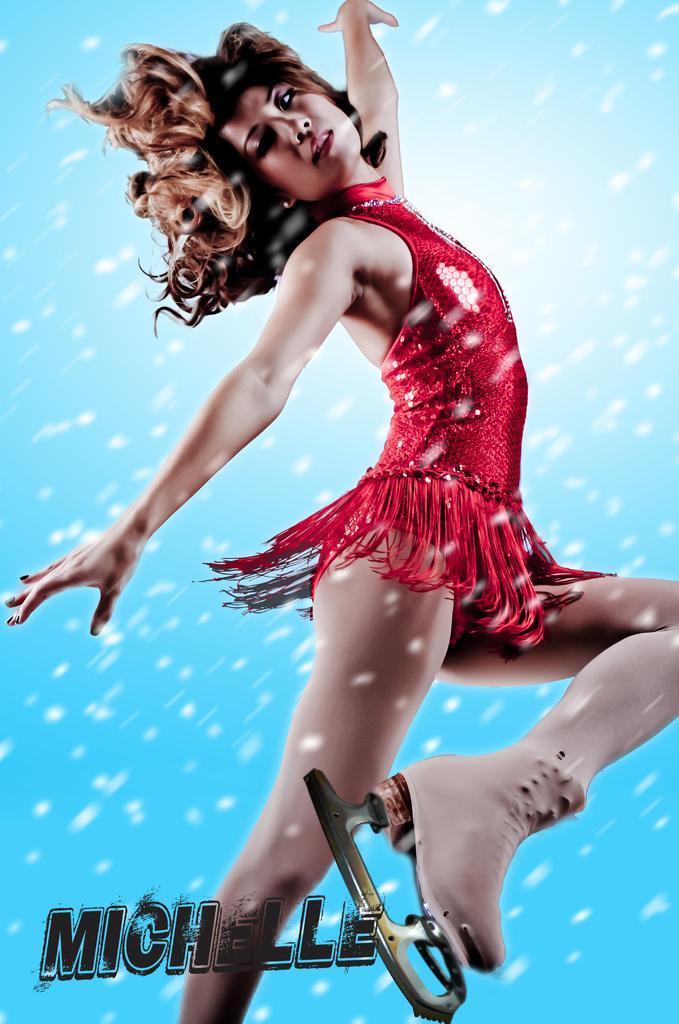How would you summarize this image in a sentence or two? In this image, in the middle, we can see a woman wearing red color dress. In the background, we can see blue color. 